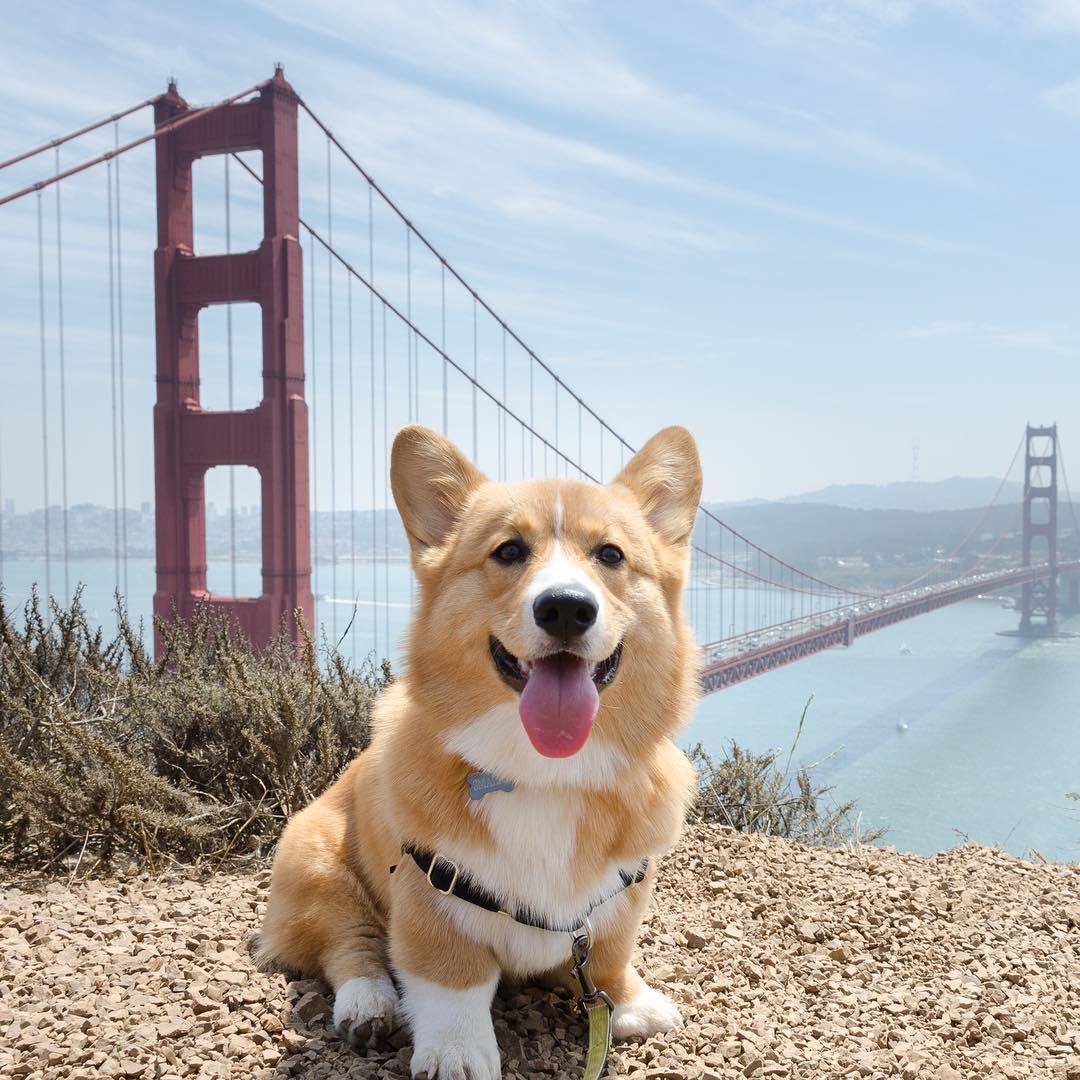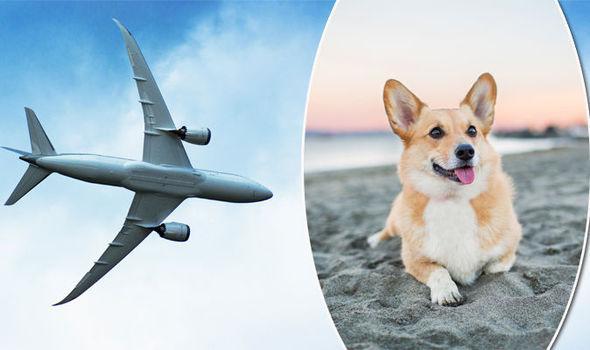The first image is the image on the left, the second image is the image on the right. Considering the images on both sides, is "An image shows one orange-and-white corgi dog posed on the shore in front of water and looking at the camera." valid? Answer yes or no. Yes. The first image is the image on the left, the second image is the image on the right. Given the left and right images, does the statement "The dog in the image on the right is near a body of water." hold true? Answer yes or no. Yes. 